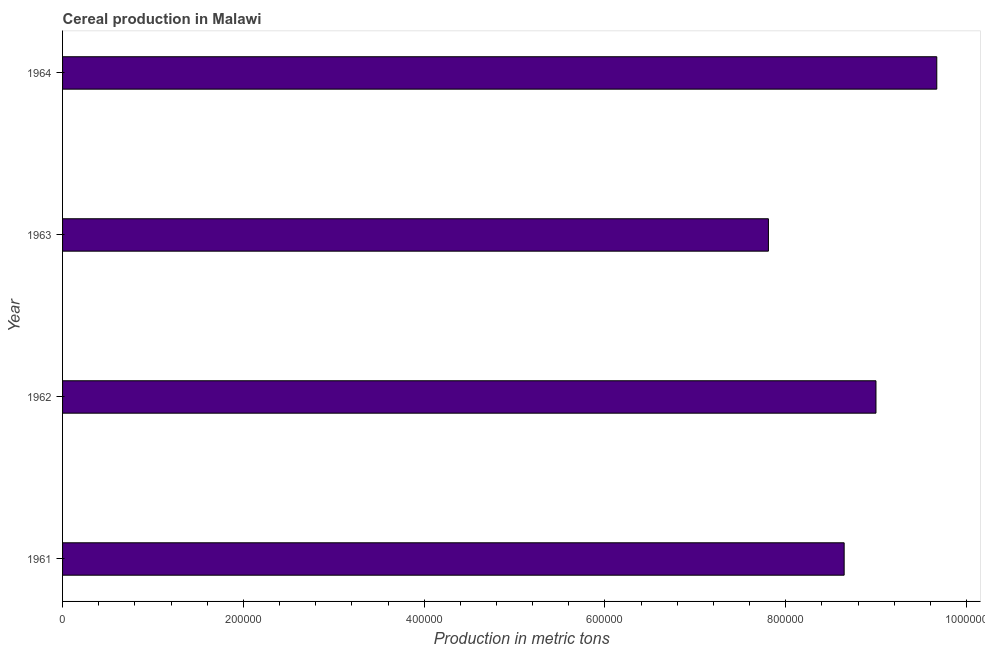What is the title of the graph?
Your answer should be very brief. Cereal production in Malawi. What is the label or title of the X-axis?
Provide a short and direct response. Production in metric tons. What is the cereal production in 1963?
Your answer should be compact. 7.81e+05. Across all years, what is the maximum cereal production?
Your answer should be compact. 9.67e+05. Across all years, what is the minimum cereal production?
Provide a succinct answer. 7.81e+05. In which year was the cereal production maximum?
Give a very brief answer. 1964. What is the sum of the cereal production?
Make the answer very short. 3.51e+06. What is the difference between the cereal production in 1962 and 1964?
Keep it short and to the point. -6.73e+04. What is the average cereal production per year?
Keep it short and to the point. 8.78e+05. What is the median cereal production?
Make the answer very short. 8.82e+05. In how many years, is the cereal production greater than 600000 metric tons?
Give a very brief answer. 4. What is the ratio of the cereal production in 1961 to that in 1962?
Make the answer very short. 0.96. Is the cereal production in 1963 less than that in 1964?
Your response must be concise. Yes. Is the difference between the cereal production in 1961 and 1963 greater than the difference between any two years?
Keep it short and to the point. No. What is the difference between the highest and the second highest cereal production?
Your response must be concise. 6.73e+04. Is the sum of the cereal production in 1961 and 1964 greater than the maximum cereal production across all years?
Give a very brief answer. Yes. What is the difference between the highest and the lowest cereal production?
Provide a short and direct response. 1.86e+05. In how many years, is the cereal production greater than the average cereal production taken over all years?
Provide a succinct answer. 2. How many bars are there?
Offer a very short reply. 4. Are all the bars in the graph horizontal?
Your answer should be very brief. Yes. How many years are there in the graph?
Your answer should be very brief. 4. What is the Production in metric tons of 1961?
Your answer should be compact. 8.65e+05. What is the Production in metric tons of 1962?
Ensure brevity in your answer.  9.00e+05. What is the Production in metric tons in 1963?
Ensure brevity in your answer.  7.81e+05. What is the Production in metric tons in 1964?
Your answer should be very brief. 9.67e+05. What is the difference between the Production in metric tons in 1961 and 1962?
Your answer should be compact. -3.52e+04. What is the difference between the Production in metric tons in 1961 and 1963?
Ensure brevity in your answer.  8.38e+04. What is the difference between the Production in metric tons in 1961 and 1964?
Your answer should be compact. -1.02e+05. What is the difference between the Production in metric tons in 1962 and 1963?
Provide a succinct answer. 1.19e+05. What is the difference between the Production in metric tons in 1962 and 1964?
Your answer should be very brief. -6.73e+04. What is the difference between the Production in metric tons in 1963 and 1964?
Offer a very short reply. -1.86e+05. What is the ratio of the Production in metric tons in 1961 to that in 1962?
Provide a succinct answer. 0.96. What is the ratio of the Production in metric tons in 1961 to that in 1963?
Give a very brief answer. 1.11. What is the ratio of the Production in metric tons in 1961 to that in 1964?
Ensure brevity in your answer.  0.89. What is the ratio of the Production in metric tons in 1962 to that in 1963?
Ensure brevity in your answer.  1.15. What is the ratio of the Production in metric tons in 1963 to that in 1964?
Your response must be concise. 0.81. 